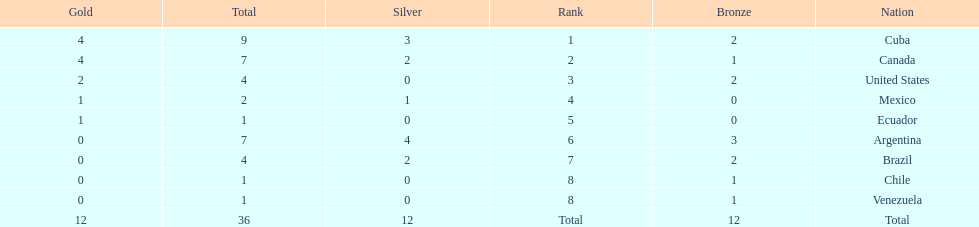Which countries have won gold medals? Cuba, Canada, United States, Mexico, Ecuador. Of these countries, which ones have never won silver or bronze medals? United States, Ecuador. Of the two nations listed previously, which one has only won a gold medal? Ecuador. 